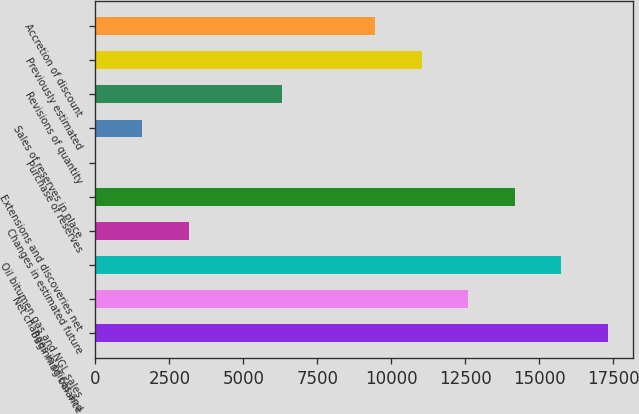<chart> <loc_0><loc_0><loc_500><loc_500><bar_chart><fcel>Beginning balance<fcel>Net changes in prices and<fcel>Oil bitumen gas and NGL sales<fcel>Changes in estimated future<fcel>Extensions and discoveries net<fcel>Purchase of reserves<fcel>Sales of reserves in place<fcel>Revisions of quantity<fcel>Previously estimated<fcel>Accretion of discount<nl><fcel>17313.7<fcel>12595.6<fcel>15741<fcel>3159.4<fcel>14168.3<fcel>14<fcel>1586.7<fcel>6304.8<fcel>11022.9<fcel>9450.2<nl></chart> 